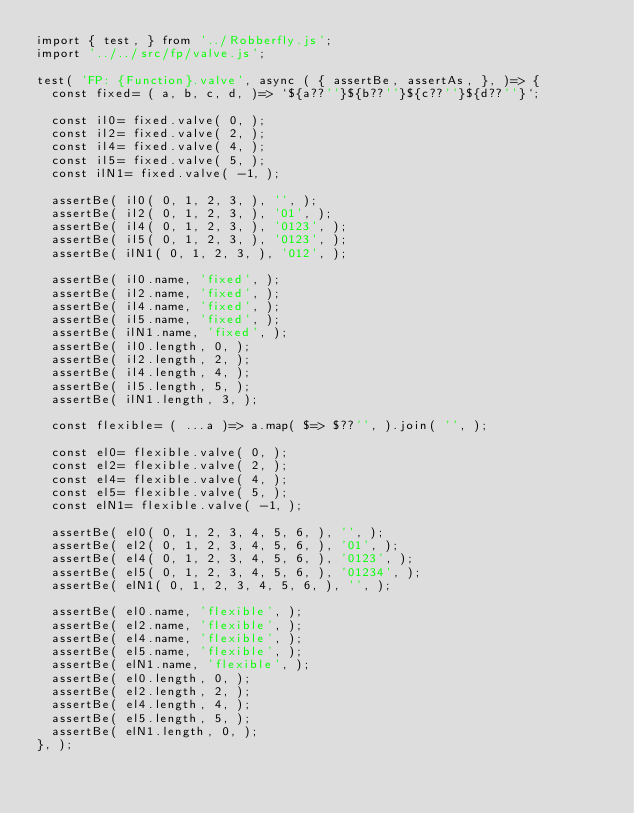Convert code to text. <code><loc_0><loc_0><loc_500><loc_500><_JavaScript_>import { test, } from '../Robberfly.js';
import '../../src/fp/valve.js';

test( 'FP: {Function}.valve', async ( { assertBe, assertAs, }, )=> {
	const fixed= ( a, b, c, d, )=> `${a??''}${b??''}${c??''}${d??''}`;
	
	const il0= fixed.valve( 0, );
	const il2= fixed.valve( 2, );
	const il4= fixed.valve( 4, );
	const il5= fixed.valve( 5, );
	const ilN1= fixed.valve( -1, );
	
	assertBe( il0( 0, 1, 2, 3, ), '', );
	assertBe( il2( 0, 1, 2, 3, ), '01', );
	assertBe( il4( 0, 1, 2, 3, ), '0123', );
	assertBe( il5( 0, 1, 2, 3, ), '0123', );
	assertBe( ilN1( 0, 1, 2, 3, ), '012', );
	
	assertBe( il0.name, 'fixed', );
	assertBe( il2.name, 'fixed', );
	assertBe( il4.name, 'fixed', );
	assertBe( il5.name, 'fixed', );
	assertBe( ilN1.name, 'fixed', );
	assertBe( il0.length, 0, );
	assertBe( il2.length, 2, );
	assertBe( il4.length, 4, );
	assertBe( il5.length, 5, );
	assertBe( ilN1.length, 3, );
	
	const flexible= ( ...a )=> a.map( $=> $??'', ).join( '', );
	
	const el0= flexible.valve( 0, );
	const el2= flexible.valve( 2, );
	const el4= flexible.valve( 4, );
	const el5= flexible.valve( 5, );
	const elN1= flexible.valve( -1, );
	
	assertBe( el0( 0, 1, 2, 3, 4, 5, 6, ), '', );
	assertBe( el2( 0, 1, 2, 3, 4, 5, 6, ), '01', );
	assertBe( el4( 0, 1, 2, 3, 4, 5, 6, ), '0123', );
	assertBe( el5( 0, 1, 2, 3, 4, 5, 6, ), '01234', );
	assertBe( elN1( 0, 1, 2, 3, 4, 5, 6, ), '', );
	
	assertBe( el0.name, 'flexible', );
	assertBe( el2.name, 'flexible', );
	assertBe( el4.name, 'flexible', );
	assertBe( el5.name, 'flexible', );
	assertBe( elN1.name, 'flexible', );
	assertBe( el0.length, 0, );
	assertBe( el2.length, 2, );
	assertBe( el4.length, 4, );
	assertBe( el5.length, 5, );
	assertBe( elN1.length, 0, );
}, );
</code> 